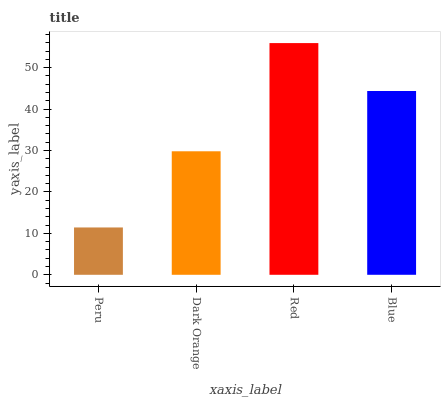Is Dark Orange the minimum?
Answer yes or no. No. Is Dark Orange the maximum?
Answer yes or no. No. Is Dark Orange greater than Peru?
Answer yes or no. Yes. Is Peru less than Dark Orange?
Answer yes or no. Yes. Is Peru greater than Dark Orange?
Answer yes or no. No. Is Dark Orange less than Peru?
Answer yes or no. No. Is Blue the high median?
Answer yes or no. Yes. Is Dark Orange the low median?
Answer yes or no. Yes. Is Peru the high median?
Answer yes or no. No. Is Red the low median?
Answer yes or no. No. 